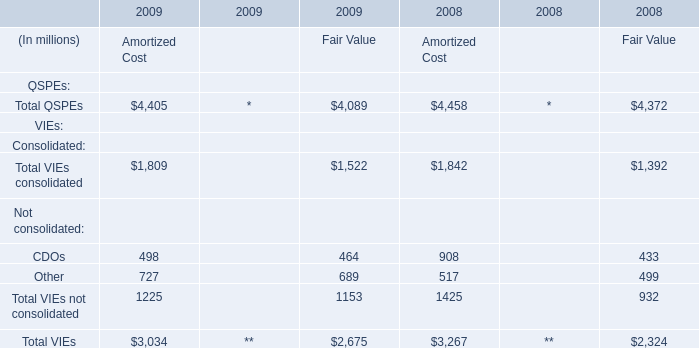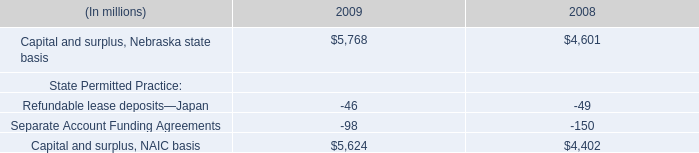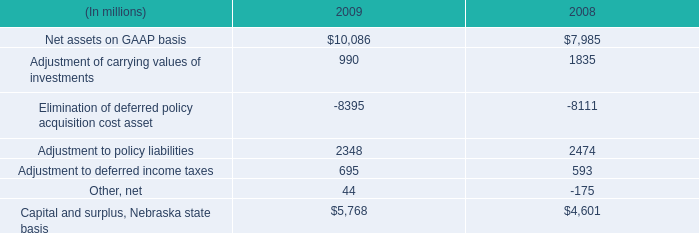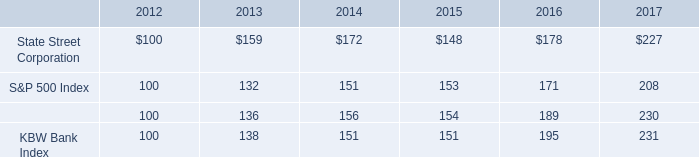What is the average amount of Capital and surplus, Nebraska state basis of 2009, and Capital and surplus, Nebraska state basis of 2009 ? 
Computations: ((5768.0 + 5768.0) / 2)
Answer: 5768.0. 